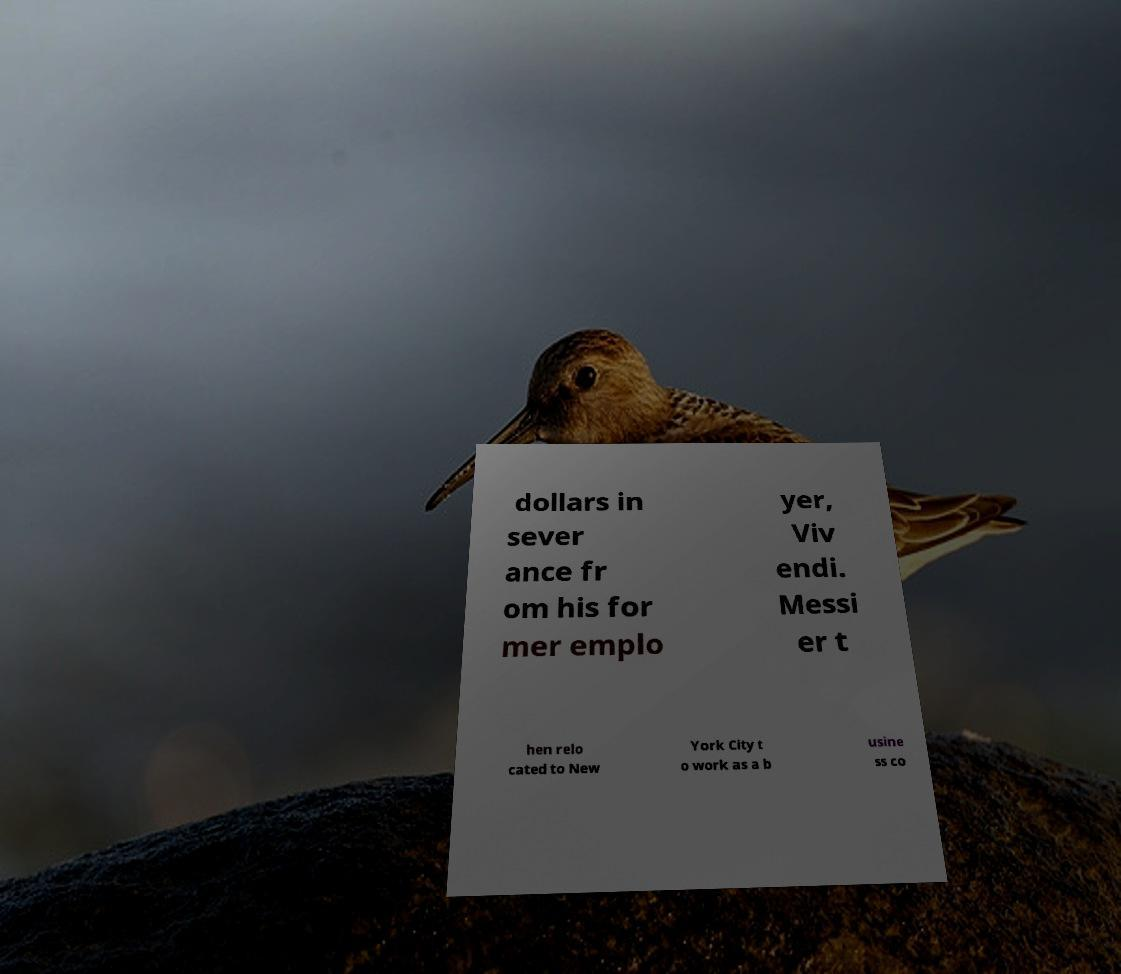For documentation purposes, I need the text within this image transcribed. Could you provide that? dollars in sever ance fr om his for mer emplo yer, Viv endi. Messi er t hen relo cated to New York City t o work as a b usine ss co 